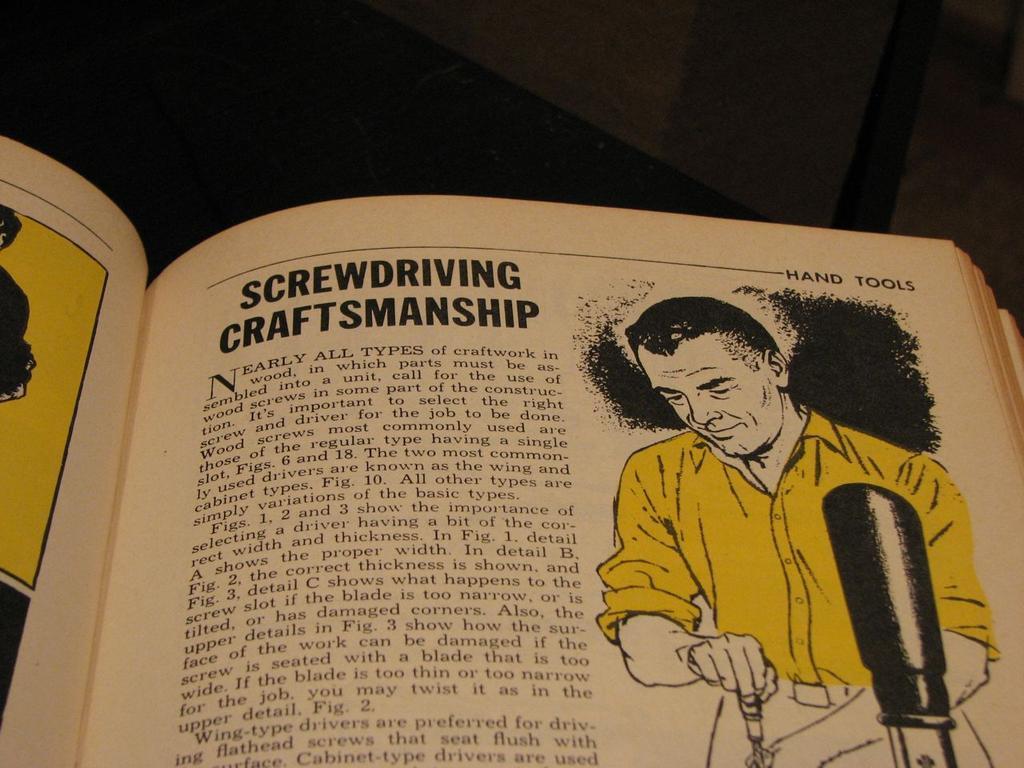What is the title of this page (in bold)?
Provide a short and direct response. Screwdriving craftsmanship. What type of tools is this section based upon?
Offer a very short reply. Screwdriver. 